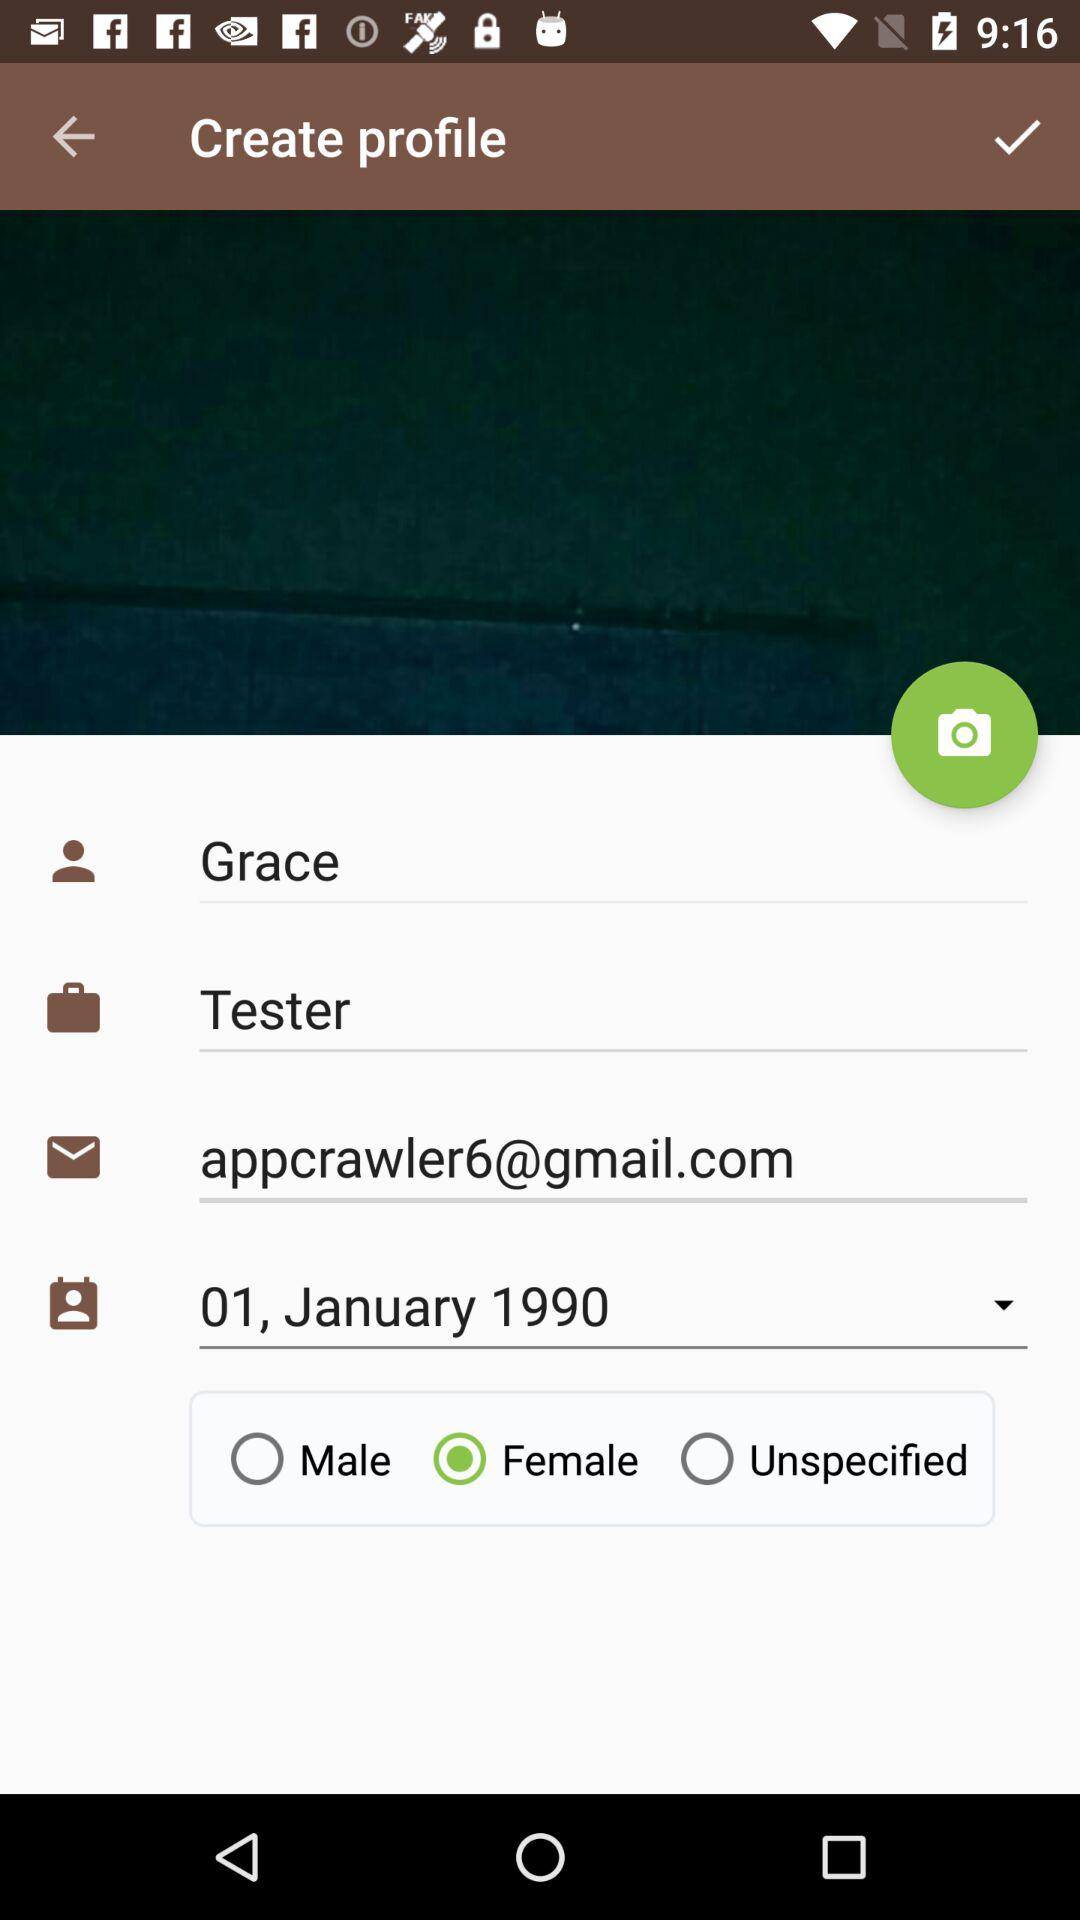What is the name of the user? The name of the user is Grace. 